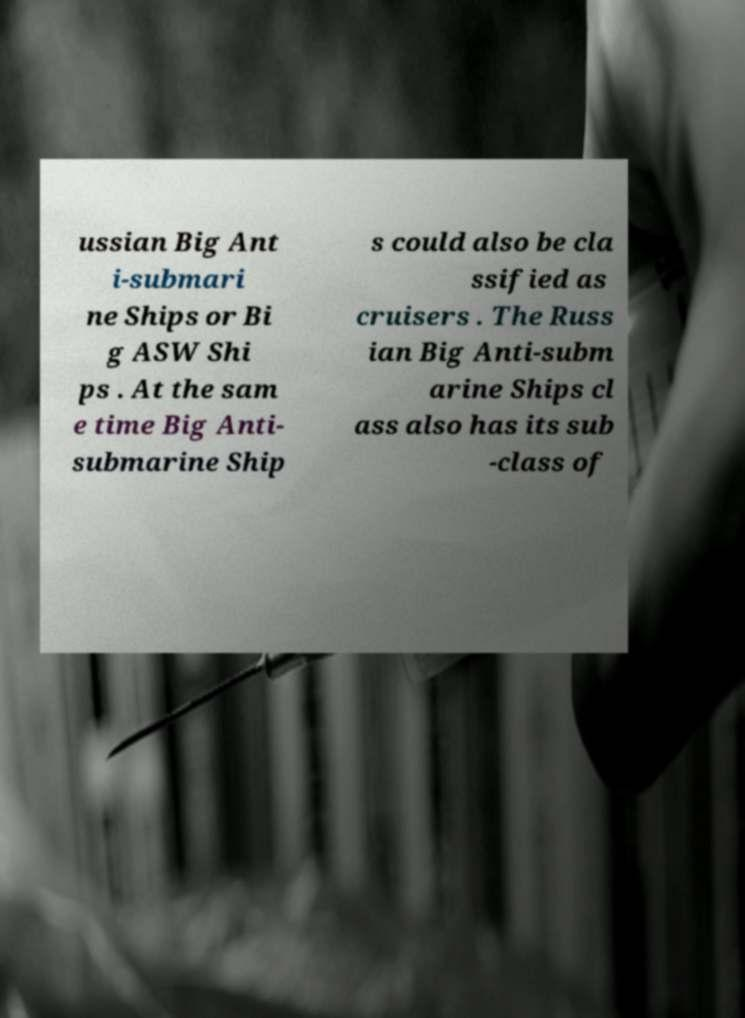Please identify and transcribe the text found in this image. ussian Big Ant i-submari ne Ships or Bi g ASW Shi ps . At the sam e time Big Anti- submarine Ship s could also be cla ssified as cruisers . The Russ ian Big Anti-subm arine Ships cl ass also has its sub -class of 